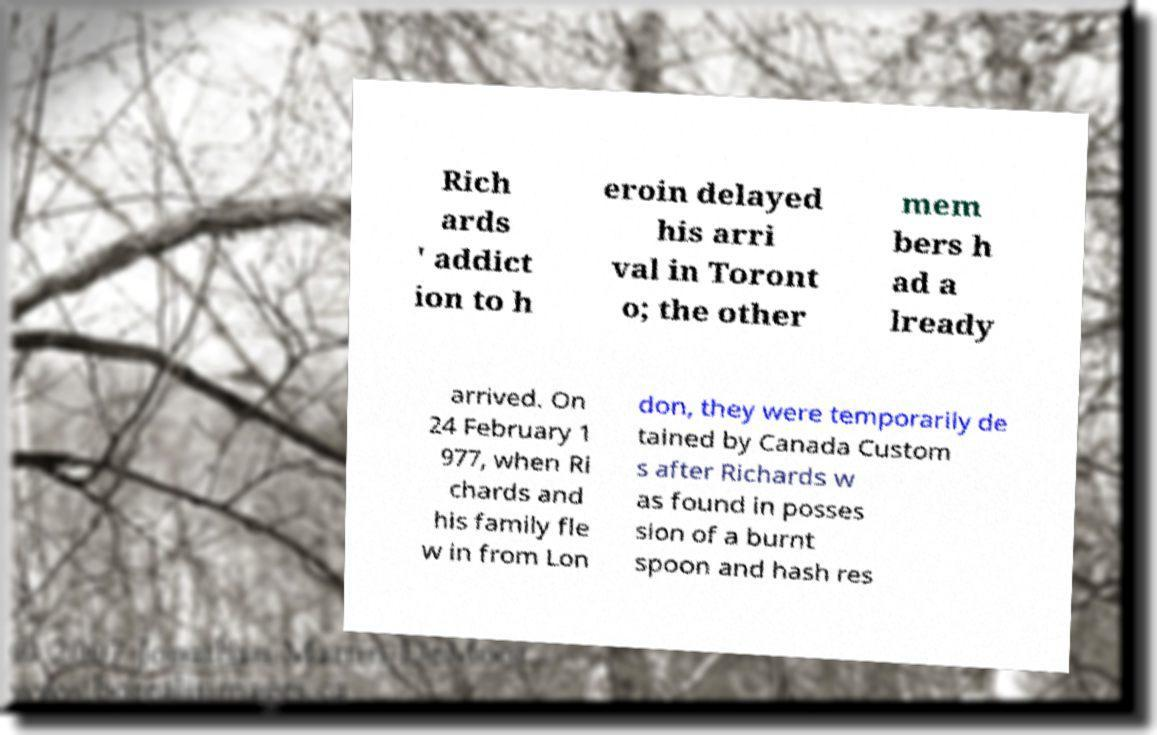Could you assist in decoding the text presented in this image and type it out clearly? Rich ards ' addict ion to h eroin delayed his arri val in Toront o; the other mem bers h ad a lready arrived. On 24 February 1 977, when Ri chards and his family fle w in from Lon don, they were temporarily de tained by Canada Custom s after Richards w as found in posses sion of a burnt spoon and hash res 